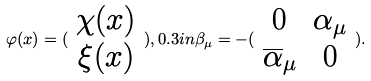<formula> <loc_0><loc_0><loc_500><loc_500>\varphi ( x ) = ( \begin{array} { c } \chi ( x ) \\ \xi ( x ) \end{array} ) , 0 . 3 i n \beta _ { \mu } = - ( \begin{array} { c c } 0 & \alpha _ { \mu } \\ \overline { \alpha } _ { \mu } & 0 \end{array} ) .</formula> 